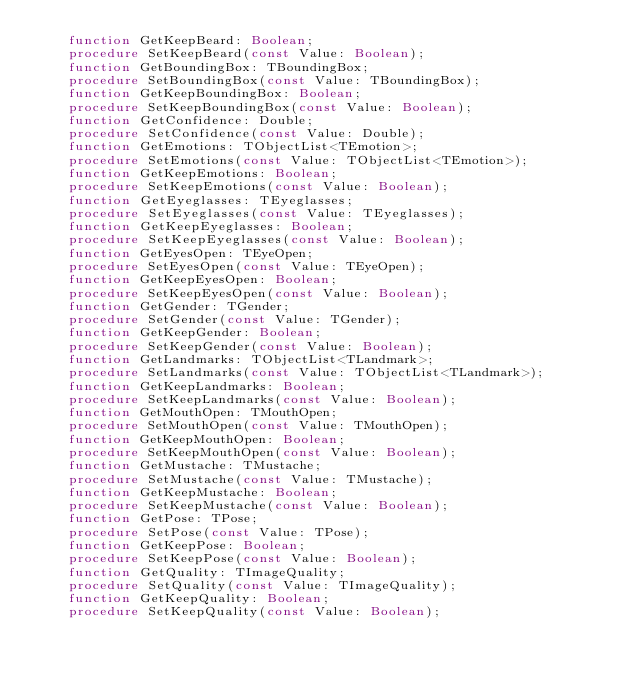Convert code to text. <code><loc_0><loc_0><loc_500><loc_500><_Pascal_>    function GetKeepBeard: Boolean;
    procedure SetKeepBeard(const Value: Boolean);
    function GetBoundingBox: TBoundingBox;
    procedure SetBoundingBox(const Value: TBoundingBox);
    function GetKeepBoundingBox: Boolean;
    procedure SetKeepBoundingBox(const Value: Boolean);
    function GetConfidence: Double;
    procedure SetConfidence(const Value: Double);
    function GetEmotions: TObjectList<TEmotion>;
    procedure SetEmotions(const Value: TObjectList<TEmotion>);
    function GetKeepEmotions: Boolean;
    procedure SetKeepEmotions(const Value: Boolean);
    function GetEyeglasses: TEyeglasses;
    procedure SetEyeglasses(const Value: TEyeglasses);
    function GetKeepEyeglasses: Boolean;
    procedure SetKeepEyeglasses(const Value: Boolean);
    function GetEyesOpen: TEyeOpen;
    procedure SetEyesOpen(const Value: TEyeOpen);
    function GetKeepEyesOpen: Boolean;
    procedure SetKeepEyesOpen(const Value: Boolean);
    function GetGender: TGender;
    procedure SetGender(const Value: TGender);
    function GetKeepGender: Boolean;
    procedure SetKeepGender(const Value: Boolean);
    function GetLandmarks: TObjectList<TLandmark>;
    procedure SetLandmarks(const Value: TObjectList<TLandmark>);
    function GetKeepLandmarks: Boolean;
    procedure SetKeepLandmarks(const Value: Boolean);
    function GetMouthOpen: TMouthOpen;
    procedure SetMouthOpen(const Value: TMouthOpen);
    function GetKeepMouthOpen: Boolean;
    procedure SetKeepMouthOpen(const Value: Boolean);
    function GetMustache: TMustache;
    procedure SetMustache(const Value: TMustache);
    function GetKeepMustache: Boolean;
    procedure SetKeepMustache(const Value: Boolean);
    function GetPose: TPose;
    procedure SetPose(const Value: TPose);
    function GetKeepPose: Boolean;
    procedure SetKeepPose(const Value: Boolean);
    function GetQuality: TImageQuality;
    procedure SetQuality(const Value: TImageQuality);
    function GetKeepQuality: Boolean;
    procedure SetKeepQuality(const Value: Boolean);</code> 